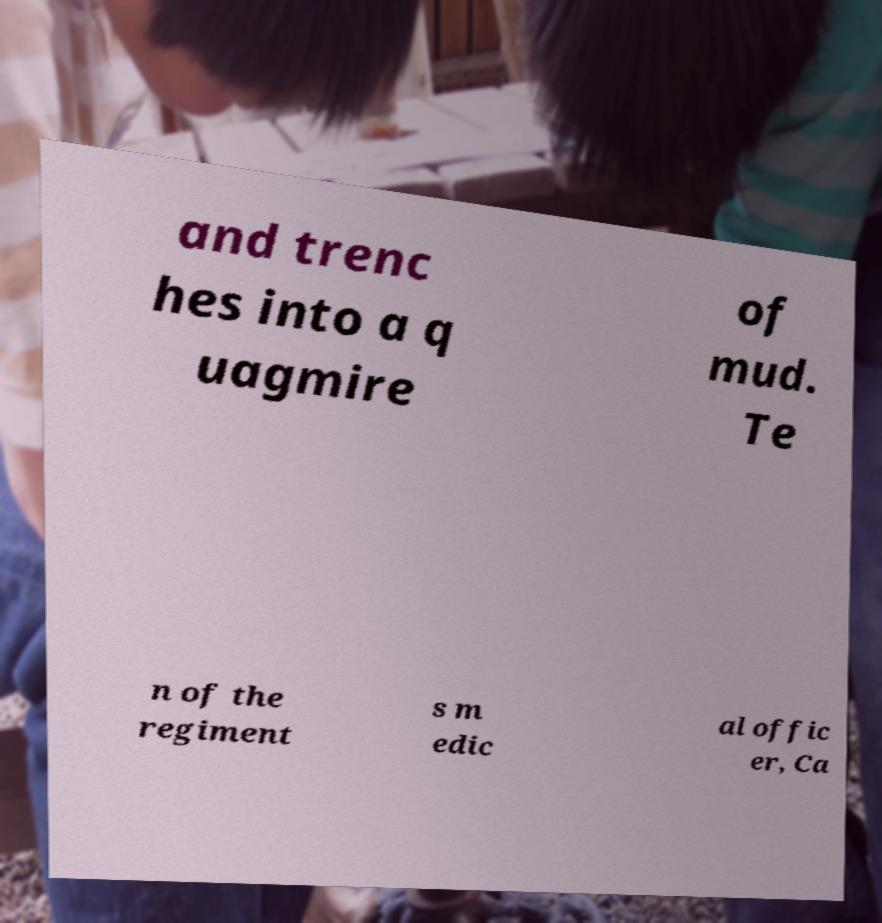Could you assist in decoding the text presented in this image and type it out clearly? and trenc hes into a q uagmire of mud. Te n of the regiment s m edic al offic er, Ca 